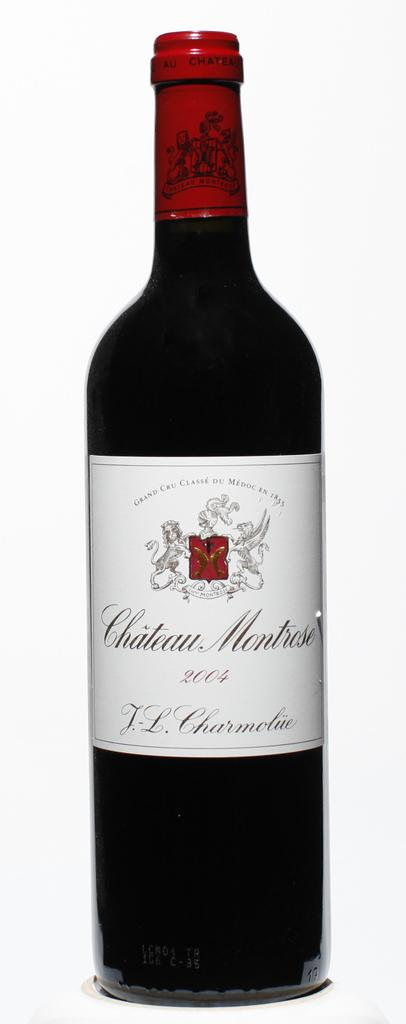<image>
Describe the image concisely. A bottle of Chateau Montrose made in 2004. 